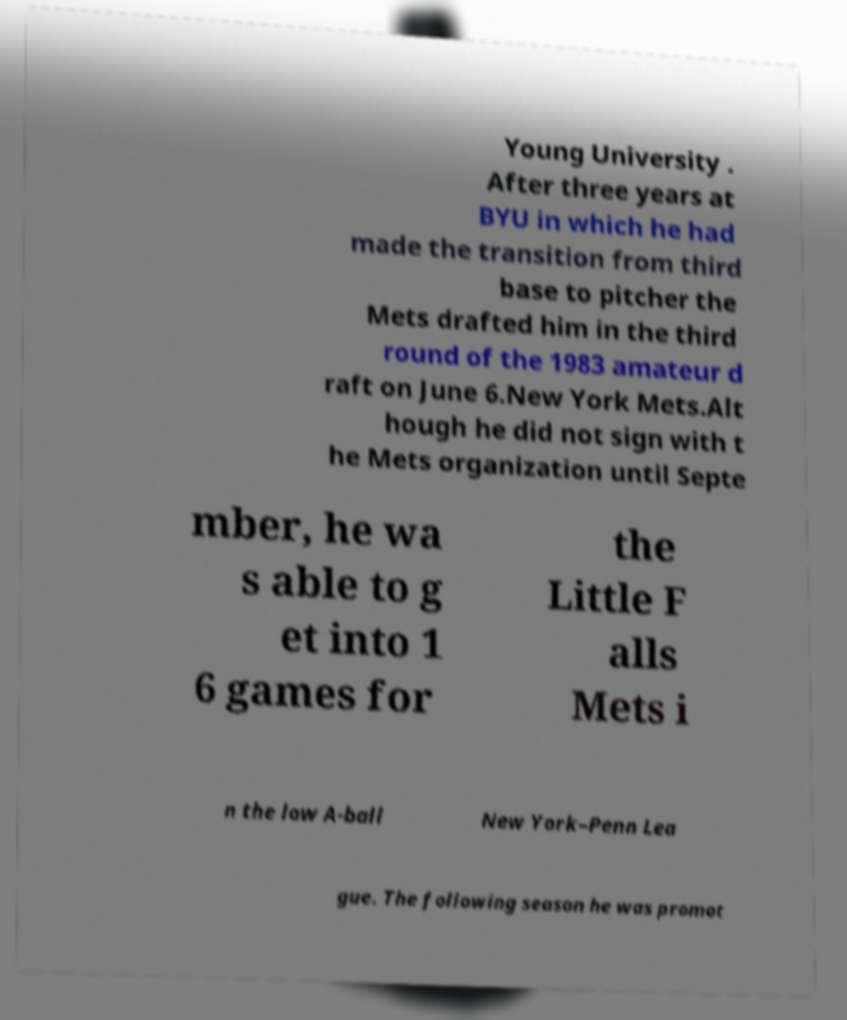Can you accurately transcribe the text from the provided image for me? Young University . After three years at BYU in which he had made the transition from third base to pitcher the Mets drafted him in the third round of the 1983 amateur d raft on June 6.New York Mets.Alt hough he did not sign with t he Mets organization until Septe mber, he wa s able to g et into 1 6 games for the Little F alls Mets i n the low A-ball New York–Penn Lea gue. The following season he was promot 